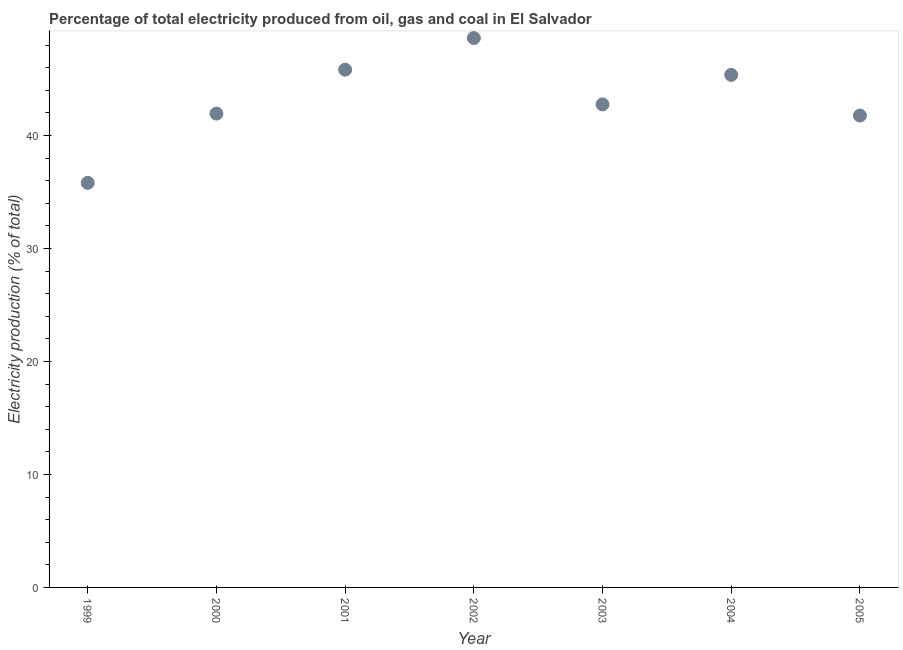What is the electricity production in 2004?
Provide a succinct answer. 45.36. Across all years, what is the maximum electricity production?
Provide a succinct answer. 48.61. Across all years, what is the minimum electricity production?
Offer a very short reply. 35.8. In which year was the electricity production minimum?
Provide a short and direct response. 1999. What is the sum of the electricity production?
Your response must be concise. 302.02. What is the difference between the electricity production in 2002 and 2005?
Your response must be concise. 6.86. What is the average electricity production per year?
Give a very brief answer. 43.15. What is the median electricity production?
Provide a succinct answer. 42.74. In how many years, is the electricity production greater than 6 %?
Give a very brief answer. 7. Do a majority of the years between 2001 and 2002 (inclusive) have electricity production greater than 26 %?
Keep it short and to the point. Yes. What is the ratio of the electricity production in 2002 to that in 2004?
Provide a succinct answer. 1.07. What is the difference between the highest and the second highest electricity production?
Provide a succinct answer. 2.8. What is the difference between the highest and the lowest electricity production?
Your answer should be compact. 12.81. In how many years, is the electricity production greater than the average electricity production taken over all years?
Provide a succinct answer. 3. Does the electricity production monotonically increase over the years?
Keep it short and to the point. No. What is the difference between two consecutive major ticks on the Y-axis?
Make the answer very short. 10. Are the values on the major ticks of Y-axis written in scientific E-notation?
Give a very brief answer. No. Does the graph contain any zero values?
Your answer should be compact. No. What is the title of the graph?
Your answer should be compact. Percentage of total electricity produced from oil, gas and coal in El Salvador. What is the label or title of the X-axis?
Keep it short and to the point. Year. What is the label or title of the Y-axis?
Give a very brief answer. Electricity production (% of total). What is the Electricity production (% of total) in 1999?
Your answer should be very brief. 35.8. What is the Electricity production (% of total) in 2000?
Keep it short and to the point. 41.93. What is the Electricity production (% of total) in 2001?
Make the answer very short. 45.82. What is the Electricity production (% of total) in 2002?
Provide a short and direct response. 48.61. What is the Electricity production (% of total) in 2003?
Provide a short and direct response. 42.74. What is the Electricity production (% of total) in 2004?
Ensure brevity in your answer.  45.36. What is the Electricity production (% of total) in 2005?
Offer a very short reply. 41.76. What is the difference between the Electricity production (% of total) in 1999 and 2000?
Provide a short and direct response. -6.13. What is the difference between the Electricity production (% of total) in 1999 and 2001?
Offer a very short reply. -10.01. What is the difference between the Electricity production (% of total) in 1999 and 2002?
Your answer should be compact. -12.81. What is the difference between the Electricity production (% of total) in 1999 and 2003?
Your answer should be very brief. -6.94. What is the difference between the Electricity production (% of total) in 1999 and 2004?
Provide a short and direct response. -9.55. What is the difference between the Electricity production (% of total) in 1999 and 2005?
Provide a succinct answer. -5.95. What is the difference between the Electricity production (% of total) in 2000 and 2001?
Give a very brief answer. -3.88. What is the difference between the Electricity production (% of total) in 2000 and 2002?
Your response must be concise. -6.68. What is the difference between the Electricity production (% of total) in 2000 and 2003?
Your answer should be very brief. -0.81. What is the difference between the Electricity production (% of total) in 2000 and 2004?
Provide a short and direct response. -3.43. What is the difference between the Electricity production (% of total) in 2000 and 2005?
Your response must be concise. 0.17. What is the difference between the Electricity production (% of total) in 2001 and 2002?
Ensure brevity in your answer.  -2.8. What is the difference between the Electricity production (% of total) in 2001 and 2003?
Your answer should be very brief. 3.07. What is the difference between the Electricity production (% of total) in 2001 and 2004?
Give a very brief answer. 0.46. What is the difference between the Electricity production (% of total) in 2001 and 2005?
Your response must be concise. 4.06. What is the difference between the Electricity production (% of total) in 2002 and 2003?
Offer a very short reply. 5.87. What is the difference between the Electricity production (% of total) in 2002 and 2004?
Ensure brevity in your answer.  3.26. What is the difference between the Electricity production (% of total) in 2002 and 2005?
Offer a very short reply. 6.86. What is the difference between the Electricity production (% of total) in 2003 and 2004?
Your answer should be compact. -2.61. What is the difference between the Electricity production (% of total) in 2003 and 2005?
Give a very brief answer. 0.99. What is the difference between the Electricity production (% of total) in 2004 and 2005?
Your response must be concise. 3.6. What is the ratio of the Electricity production (% of total) in 1999 to that in 2000?
Your response must be concise. 0.85. What is the ratio of the Electricity production (% of total) in 1999 to that in 2001?
Make the answer very short. 0.78. What is the ratio of the Electricity production (% of total) in 1999 to that in 2002?
Your answer should be compact. 0.74. What is the ratio of the Electricity production (% of total) in 1999 to that in 2003?
Keep it short and to the point. 0.84. What is the ratio of the Electricity production (% of total) in 1999 to that in 2004?
Keep it short and to the point. 0.79. What is the ratio of the Electricity production (% of total) in 1999 to that in 2005?
Your answer should be very brief. 0.86. What is the ratio of the Electricity production (% of total) in 2000 to that in 2001?
Give a very brief answer. 0.92. What is the ratio of the Electricity production (% of total) in 2000 to that in 2002?
Your answer should be compact. 0.86. What is the ratio of the Electricity production (% of total) in 2000 to that in 2004?
Your answer should be very brief. 0.92. What is the ratio of the Electricity production (% of total) in 2000 to that in 2005?
Your answer should be very brief. 1. What is the ratio of the Electricity production (% of total) in 2001 to that in 2002?
Your response must be concise. 0.94. What is the ratio of the Electricity production (% of total) in 2001 to that in 2003?
Provide a succinct answer. 1.07. What is the ratio of the Electricity production (% of total) in 2001 to that in 2004?
Provide a short and direct response. 1.01. What is the ratio of the Electricity production (% of total) in 2001 to that in 2005?
Your answer should be very brief. 1.1. What is the ratio of the Electricity production (% of total) in 2002 to that in 2003?
Offer a very short reply. 1.14. What is the ratio of the Electricity production (% of total) in 2002 to that in 2004?
Give a very brief answer. 1.07. What is the ratio of the Electricity production (% of total) in 2002 to that in 2005?
Keep it short and to the point. 1.16. What is the ratio of the Electricity production (% of total) in 2003 to that in 2004?
Offer a very short reply. 0.94. What is the ratio of the Electricity production (% of total) in 2004 to that in 2005?
Keep it short and to the point. 1.09. 